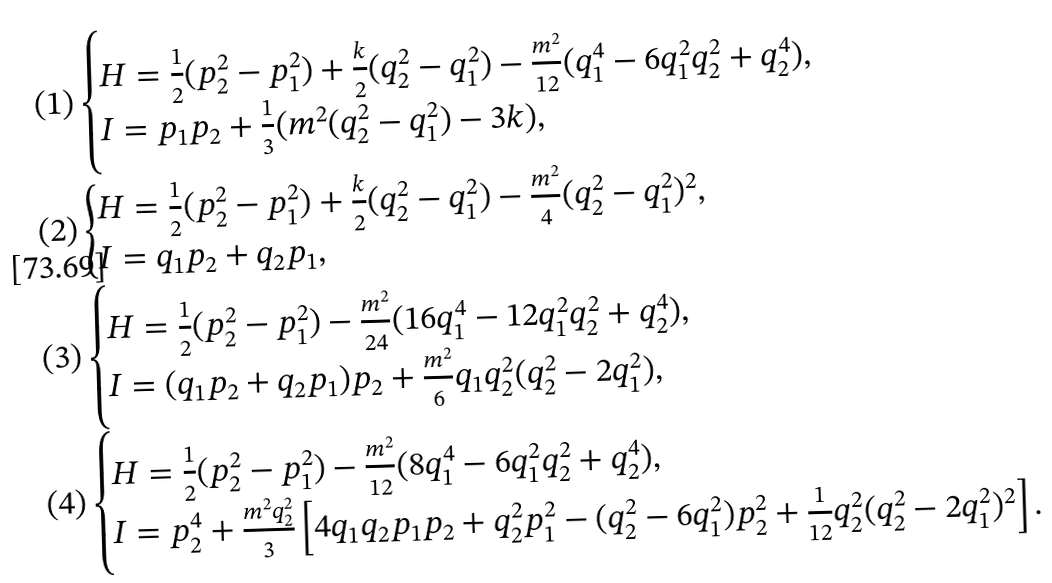<formula> <loc_0><loc_0><loc_500><loc_500>( 1 ) & \begin{cases} H = \frac { 1 } { 2 } ( p _ { 2 } ^ { 2 } - p _ { 1 } ^ { 2 } ) + \frac { k } { 2 } ( q _ { 2 } ^ { 2 } - q _ { 1 } ^ { 2 } ) - \frac { m ^ { 2 } } { 1 2 } ( q _ { 1 } ^ { 4 } - 6 q _ { 1 } ^ { 2 } q _ { 2 } ^ { 2 } + q _ { 2 } ^ { 4 } ) , \\ I = p _ { 1 } p _ { 2 } + \frac { 1 } { 3 } ( m ^ { 2 } ( q _ { 2 } ^ { 2 } - q _ { 1 } ^ { 2 } ) - 3 k ) , \end{cases} \\ ( 2 ) & \begin{cases} H = \frac { 1 } { 2 } ( p _ { 2 } ^ { 2 } - p _ { 1 } ^ { 2 } ) + \frac { k } { 2 } ( q _ { 2 } ^ { 2 } - q _ { 1 } ^ { 2 } ) - \frac { m ^ { 2 } } { 4 } ( q _ { 2 } ^ { 2 } - q _ { 1 } ^ { 2 } ) ^ { 2 } , \\ I = q _ { 1 } p _ { 2 } + q _ { 2 } p _ { 1 } , \end{cases} \\ ( 3 ) & \begin{cases} H = \frac { 1 } { 2 } ( p _ { 2 } ^ { 2 } - p _ { 1 } ^ { 2 } ) - \frac { m ^ { 2 } } { 2 4 } ( 1 6 q _ { 1 } ^ { 4 } - 1 2 q _ { 1 } ^ { 2 } q _ { 2 } ^ { 2 } + q _ { 2 } ^ { 4 } ) , \\ I = ( q _ { 1 } p _ { 2 } + q _ { 2 } p _ { 1 } ) p _ { 2 } + \frac { m ^ { 2 } } { 6 } q _ { 1 } q _ { 2 } ^ { 2 } ( q _ { 2 } ^ { 2 } - 2 q _ { 1 } ^ { 2 } ) , \end{cases} \\ ( 4 ) & \begin{cases} H = \frac { 1 } { 2 } ( p _ { 2 } ^ { 2 } - p _ { 1 } ^ { 2 } ) - \frac { m ^ { 2 } } { 1 2 } ( 8 q _ { 1 } ^ { 4 } - 6 q _ { 1 } ^ { 2 } q _ { 2 } ^ { 2 } + q _ { 2 } ^ { 4 } ) , \\ I = p _ { 2 } ^ { 4 } + \frac { m ^ { 2 } q _ { 2 } ^ { 2 } } { 3 } \left [ 4 q _ { 1 } q _ { 2 } p _ { 1 } p _ { 2 } + q _ { 2 } ^ { 2 } p _ { 1 } ^ { 2 } - ( q _ { 2 } ^ { 2 } - 6 q _ { 1 } ^ { 2 } ) p _ { 2 } ^ { 2 } + \frac { 1 } { 1 2 } q _ { 2 } ^ { 2 } ( q _ { 2 } ^ { 2 } - 2 q _ { 1 } ^ { 2 } ) ^ { 2 } \right ] . \end{cases}</formula> 